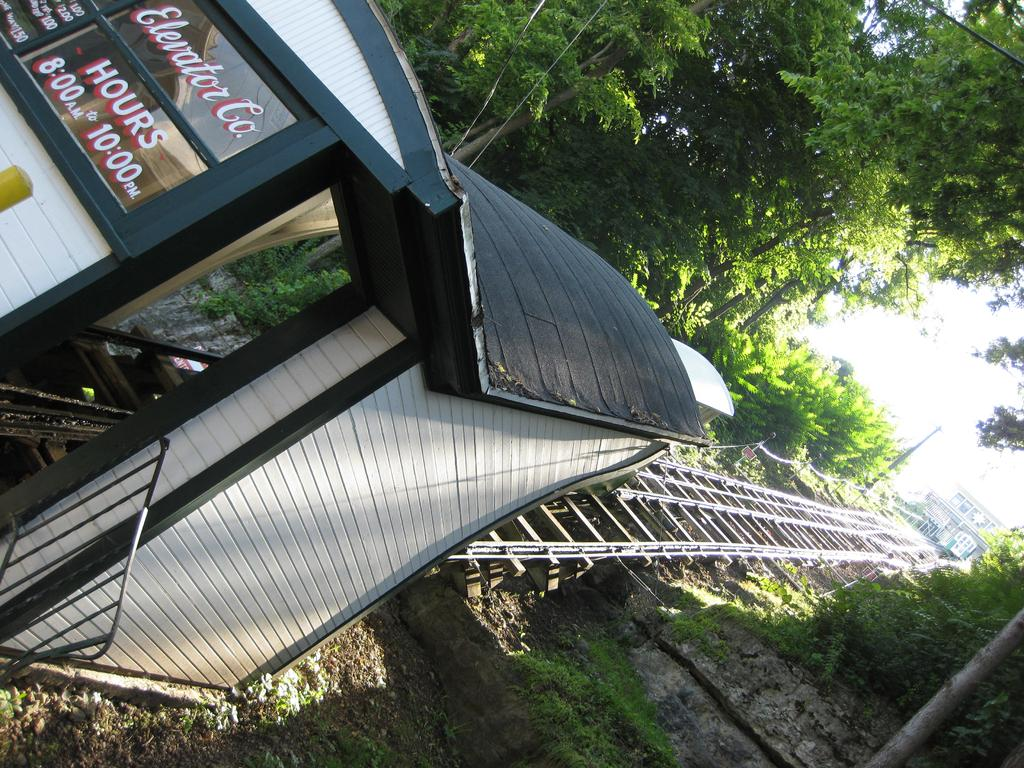What type of transportation infrastructure is visible in the image? There is a railway track in the image. What structures are present in the image? There is a wall, a roof, and a railing in the image. What can be seen on the glass in the image? Texts are written on the glass. What types of natural and man-made elements can be seen in the background of the image? In the background, there are plants, trees, buildings, and the sky. Where are the dolls placed in the image? There are no dolls present in the image. What type of stone is used to construct the wall in the image? The image does not provide information about the material used to construct the wall. 